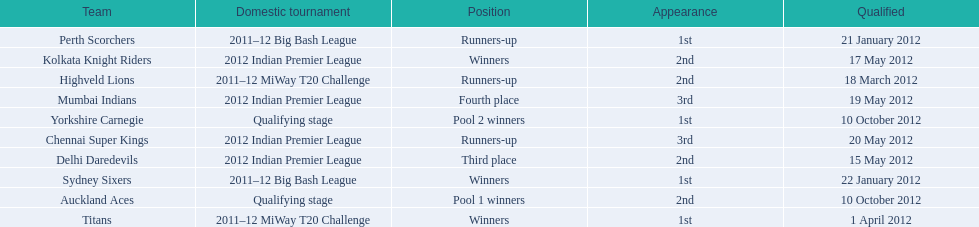Did the titans or the daredevils winners? Titans. 